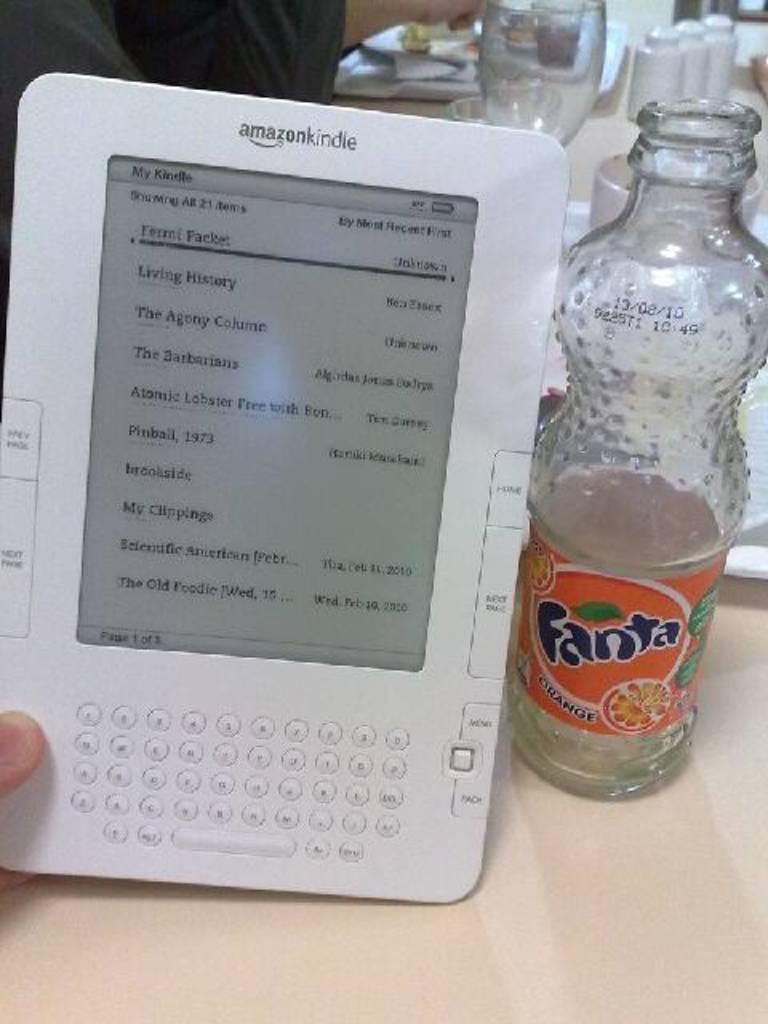Provide a one-sentence caption for the provided image. Person holding an Amazon Kindle next to an empty Fanta bottle. 